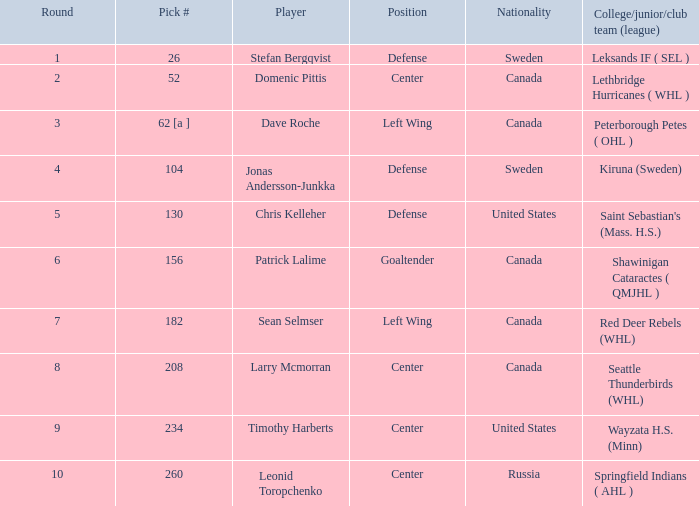Write the full table. {'header': ['Round', 'Pick #', 'Player', 'Position', 'Nationality', 'College/junior/club team (league)'], 'rows': [['1', '26', 'Stefan Bergqvist', 'Defense', 'Sweden', 'Leksands IF ( SEL )'], ['2', '52', 'Domenic Pittis', 'Center', 'Canada', 'Lethbridge Hurricanes ( WHL )'], ['3', '62 [a ]', 'Dave Roche', 'Left Wing', 'Canada', 'Peterborough Petes ( OHL )'], ['4', '104', 'Jonas Andersson-Junkka', 'Defense', 'Sweden', 'Kiruna (Sweden)'], ['5', '130', 'Chris Kelleher', 'Defense', 'United States', "Saint Sebastian's (Mass. H.S.)"], ['6', '156', 'Patrick Lalime', 'Goaltender', 'Canada', 'Shawinigan Cataractes ( QMJHL )'], ['7', '182', 'Sean Selmser', 'Left Wing', 'Canada', 'Red Deer Rebels (WHL)'], ['8', '208', 'Larry Mcmorran', 'Center', 'Canada', 'Seattle Thunderbirds (WHL)'], ['9', '234', 'Timothy Harberts', 'Center', 'United States', 'Wayzata H.S. (Minn)'], ['10', '260', 'Leonid Toropchenko', 'Center', 'Russia', 'Springfield Indians ( AHL )']]} What is the collegiate/junior/club unit (league) of the player who was drafted at 130th position? Saint Sebastian's (Mass. H.S.). 